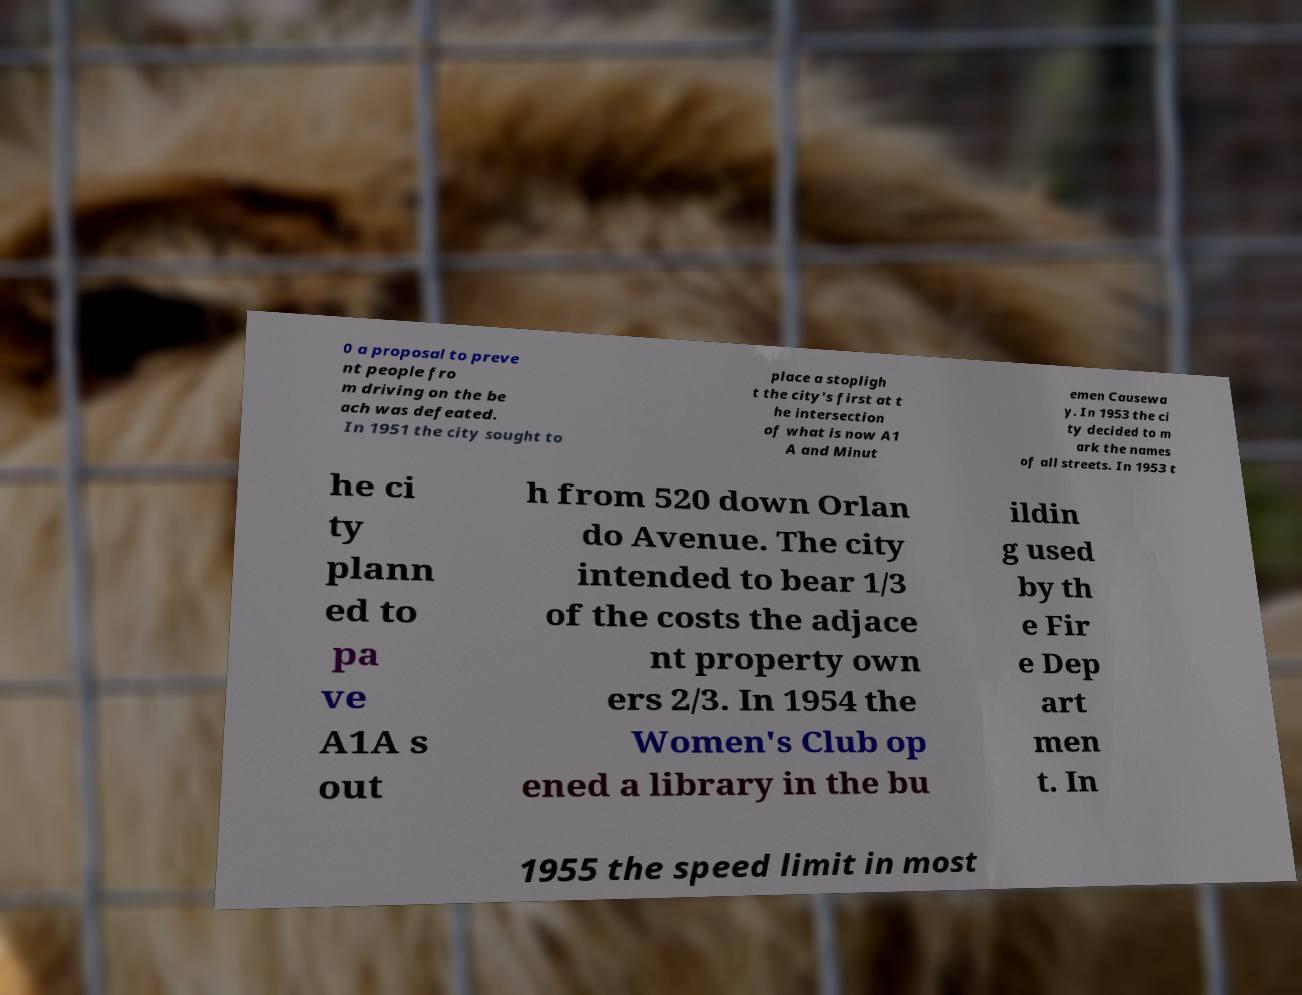There's text embedded in this image that I need extracted. Can you transcribe it verbatim? 0 a proposal to preve nt people fro m driving on the be ach was defeated. In 1951 the city sought to place a stopligh t the city's first at t he intersection of what is now A1 A and Minut emen Causewa y. In 1953 the ci ty decided to m ark the names of all streets. In 1953 t he ci ty plann ed to pa ve A1A s out h from 520 down Orlan do Avenue. The city intended to bear 1/3 of the costs the adjace nt property own ers 2/3. In 1954 the Women's Club op ened a library in the bu ildin g used by th e Fir e Dep art men t. In 1955 the speed limit in most 